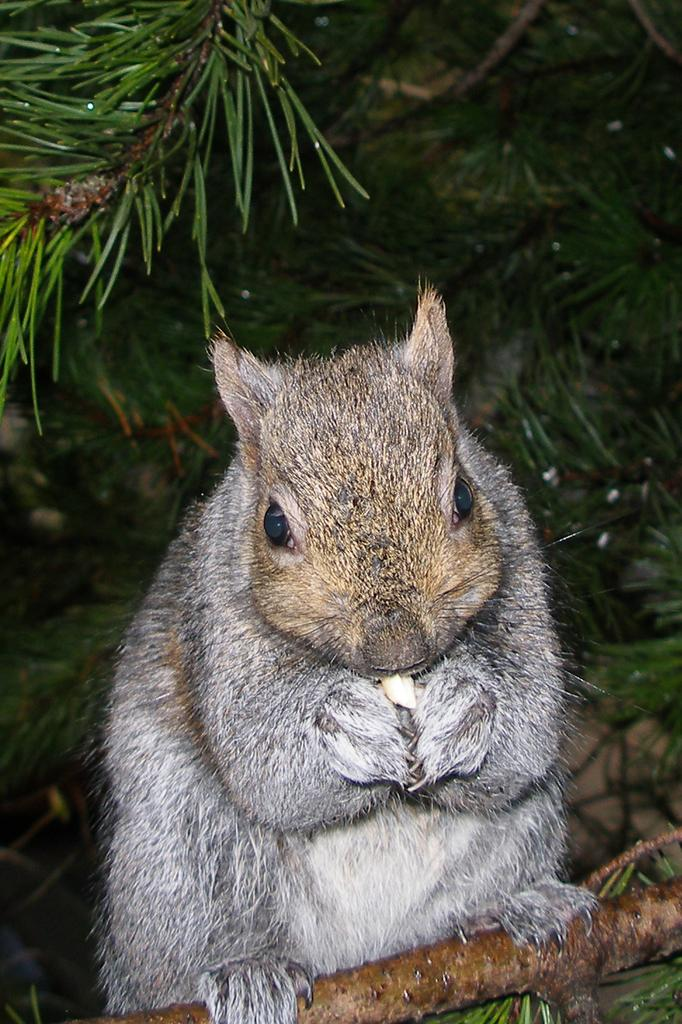What animal can be seen in the image? There is a squirrel in the image. What is visible in the background of the image? There is a tree in the background of the image. What type of iron is being used by the squirrel in the image? There is no iron present in the image, as it features a squirrel and a tree. Can you see any airplanes or airport-related structures in the image? There are no airplanes or airport-related structures present in the image. 